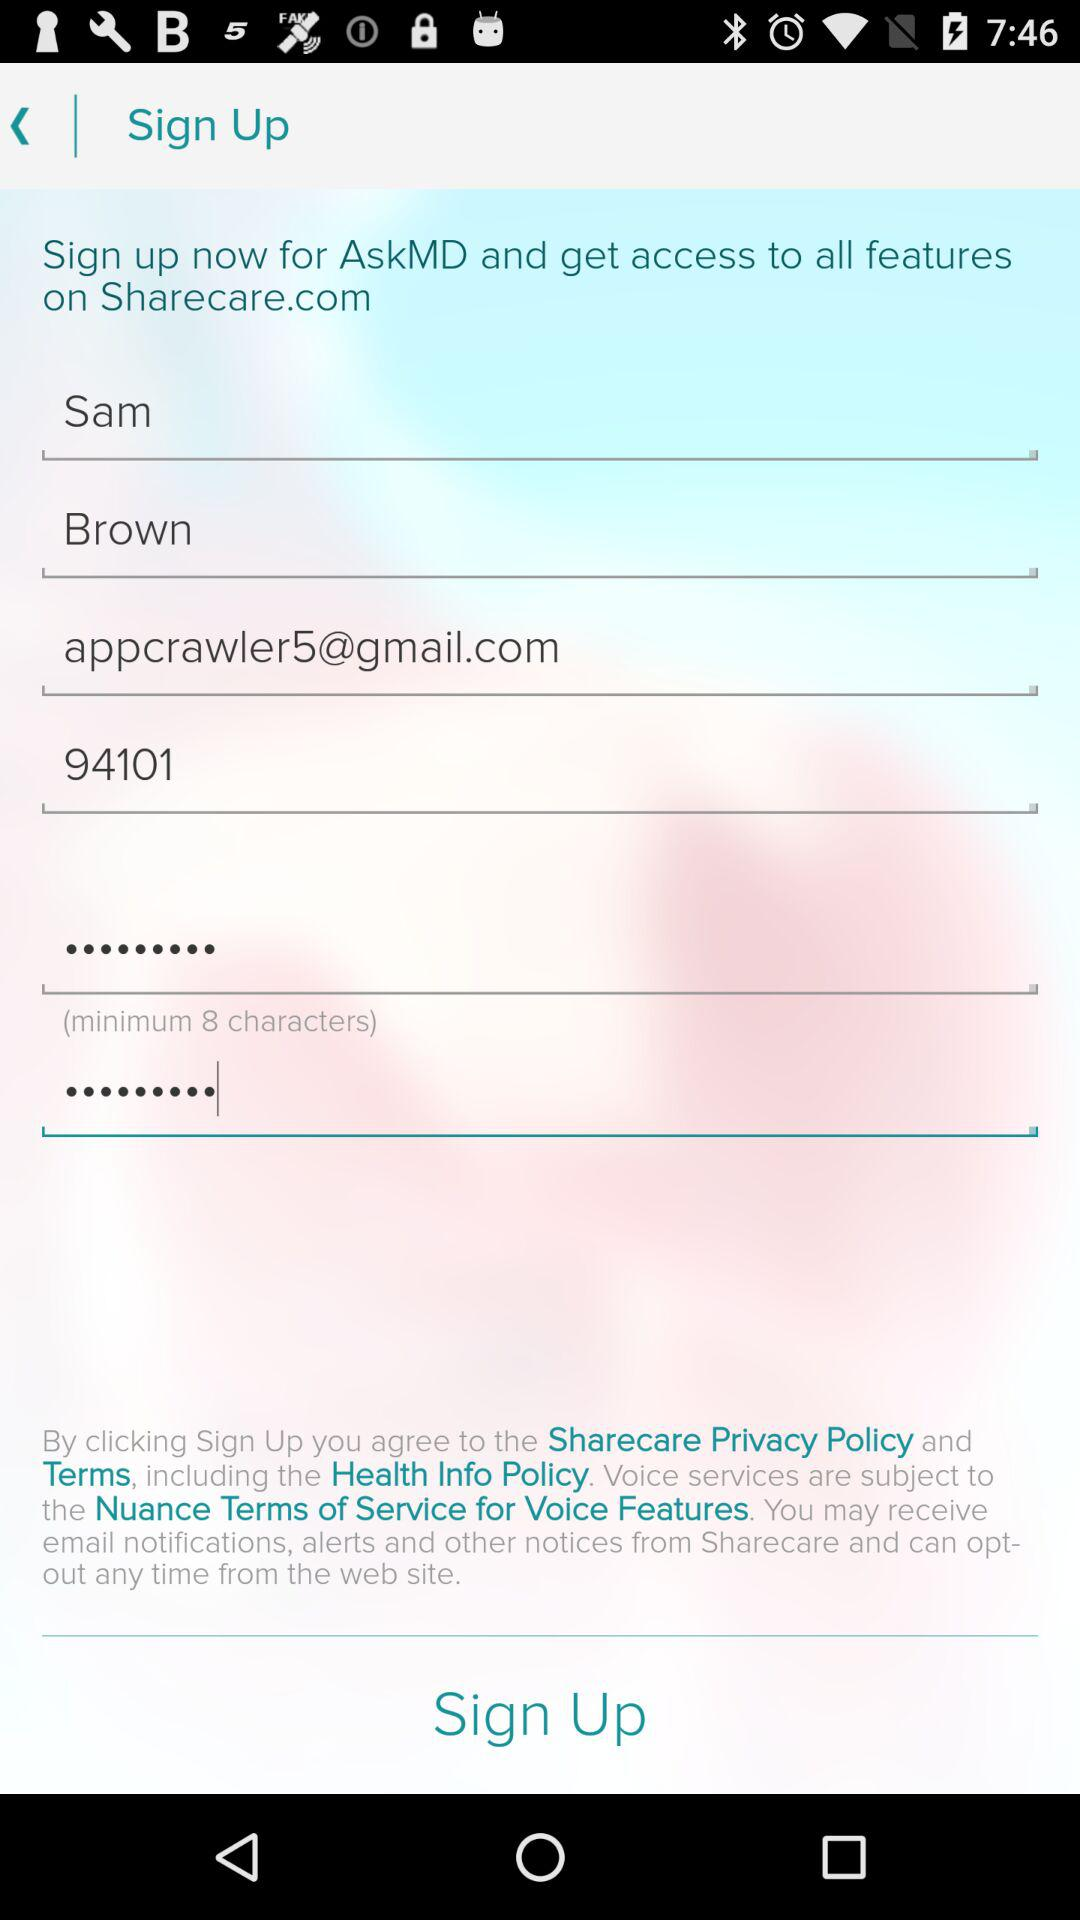What is the minimum number of characters required in the password? The minimum number of characters required in the password is 8. 